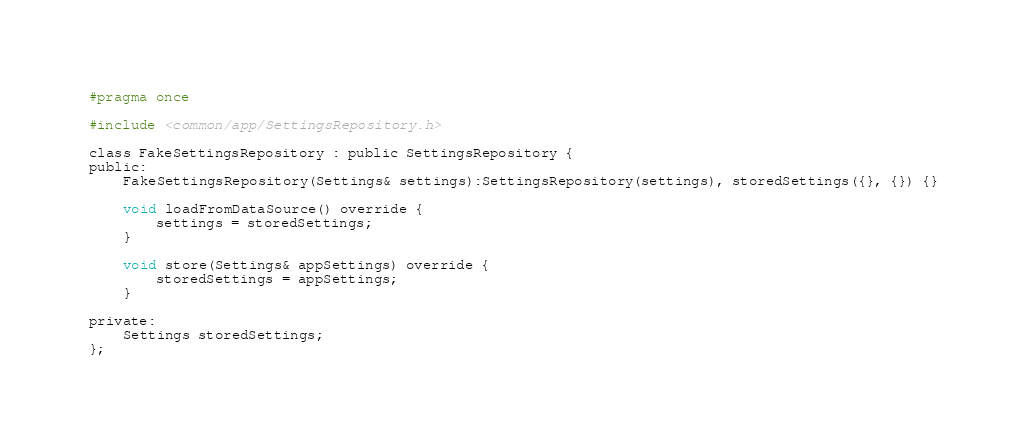Convert code to text. <code><loc_0><loc_0><loc_500><loc_500><_C_>#pragma once

#include <common/app/SettingsRepository.h>

class FakeSettingsRepository : public SettingsRepository {
public:
    FakeSettingsRepository(Settings& settings):SettingsRepository(settings), storedSettings({}, {}) {}

    void loadFromDataSource() override {
        settings = storedSettings;
    }

    void store(Settings& appSettings) override {
        storedSettings = appSettings;
    }

private:
    Settings storedSettings;
};</code> 